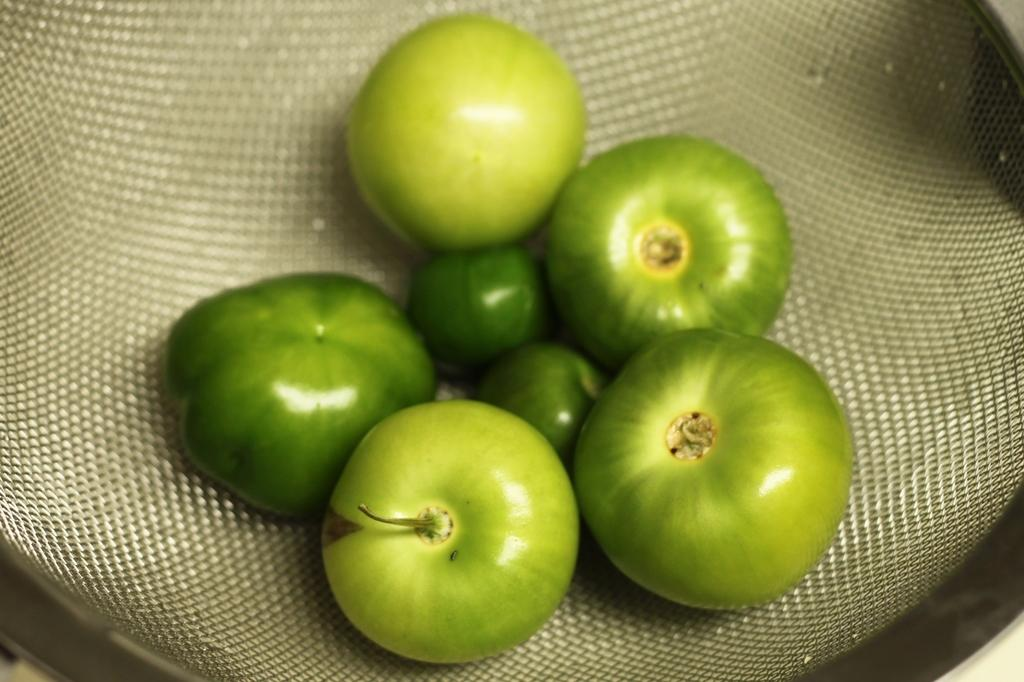What type of tomatoes are in the picture? There are green tomatoes in the picture. How are the green tomatoes arranged or placed? The green tomatoes are placed on a bag. How does the girl's digestion process affect the green tomatoes in the image? There is no girl present in the image, so her digestion process cannot affect the green tomatoes. 